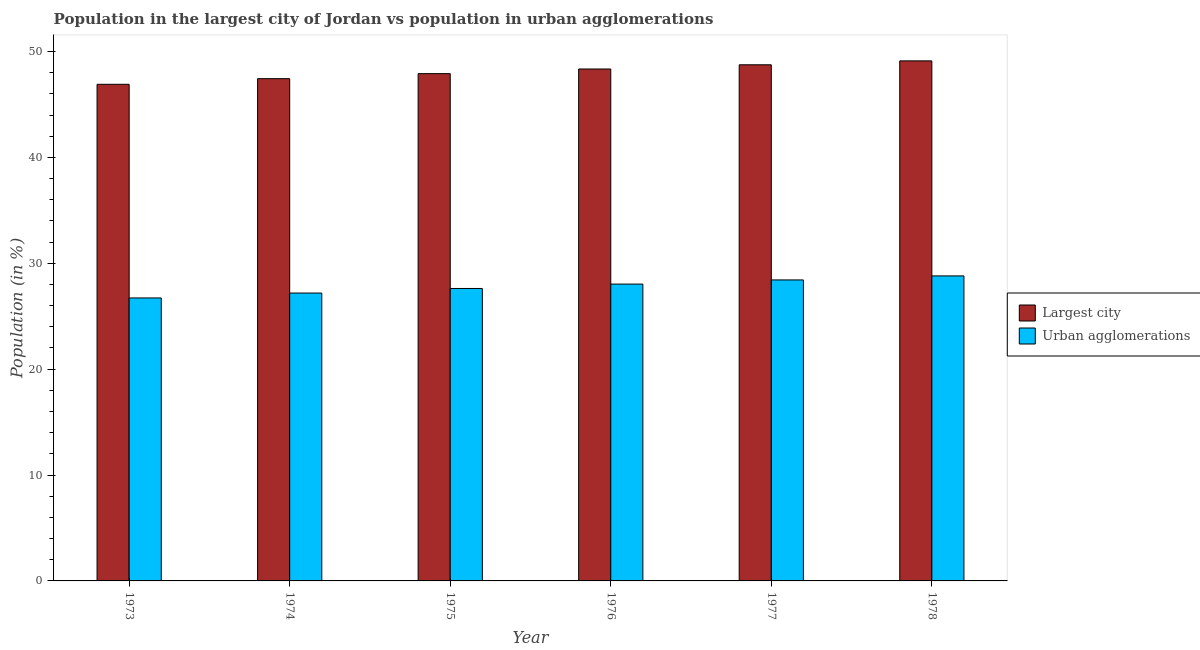How many different coloured bars are there?
Provide a short and direct response. 2. How many groups of bars are there?
Your answer should be very brief. 6. Are the number of bars per tick equal to the number of legend labels?
Offer a terse response. Yes. What is the label of the 6th group of bars from the left?
Provide a succinct answer. 1978. In how many cases, is the number of bars for a given year not equal to the number of legend labels?
Offer a very short reply. 0. What is the population in urban agglomerations in 1973?
Provide a succinct answer. 26.73. Across all years, what is the maximum population in urban agglomerations?
Your answer should be very brief. 28.81. Across all years, what is the minimum population in urban agglomerations?
Your response must be concise. 26.73. In which year was the population in the largest city maximum?
Offer a terse response. 1978. What is the total population in urban agglomerations in the graph?
Ensure brevity in your answer.  166.81. What is the difference between the population in urban agglomerations in 1973 and that in 1978?
Provide a short and direct response. -2.08. What is the difference between the population in the largest city in 1977 and the population in urban agglomerations in 1978?
Your answer should be very brief. -0.37. What is the average population in the largest city per year?
Offer a very short reply. 48.08. What is the ratio of the population in urban agglomerations in 1975 to that in 1978?
Your answer should be very brief. 0.96. Is the population in the largest city in 1975 less than that in 1978?
Offer a terse response. Yes. What is the difference between the highest and the second highest population in urban agglomerations?
Keep it short and to the point. 0.38. What is the difference between the highest and the lowest population in the largest city?
Make the answer very short. 2.21. In how many years, is the population in the largest city greater than the average population in the largest city taken over all years?
Offer a terse response. 3. What does the 2nd bar from the left in 1977 represents?
Your answer should be compact. Urban agglomerations. What does the 1st bar from the right in 1976 represents?
Offer a terse response. Urban agglomerations. How many bars are there?
Give a very brief answer. 12. Are all the bars in the graph horizontal?
Ensure brevity in your answer.  No. Does the graph contain grids?
Your answer should be compact. No. Where does the legend appear in the graph?
Make the answer very short. Center right. How are the legend labels stacked?
Your response must be concise. Vertical. What is the title of the graph?
Your answer should be compact. Population in the largest city of Jordan vs population in urban agglomerations. What is the label or title of the X-axis?
Give a very brief answer. Year. What is the label or title of the Y-axis?
Provide a short and direct response. Population (in %). What is the Population (in %) in Largest city in 1973?
Ensure brevity in your answer.  46.91. What is the Population (in %) of Urban agglomerations in 1973?
Make the answer very short. 26.73. What is the Population (in %) in Largest city in 1974?
Ensure brevity in your answer.  47.44. What is the Population (in %) of Urban agglomerations in 1974?
Keep it short and to the point. 27.19. What is the Population (in %) of Largest city in 1975?
Make the answer very short. 47.91. What is the Population (in %) in Urban agglomerations in 1975?
Ensure brevity in your answer.  27.62. What is the Population (in %) of Largest city in 1976?
Offer a terse response. 48.35. What is the Population (in %) in Urban agglomerations in 1976?
Make the answer very short. 28.04. What is the Population (in %) of Largest city in 1977?
Provide a succinct answer. 48.75. What is the Population (in %) of Urban agglomerations in 1977?
Your answer should be very brief. 28.43. What is the Population (in %) of Largest city in 1978?
Keep it short and to the point. 49.12. What is the Population (in %) of Urban agglomerations in 1978?
Give a very brief answer. 28.81. Across all years, what is the maximum Population (in %) of Largest city?
Offer a very short reply. 49.12. Across all years, what is the maximum Population (in %) in Urban agglomerations?
Offer a terse response. 28.81. Across all years, what is the minimum Population (in %) of Largest city?
Your answer should be very brief. 46.91. Across all years, what is the minimum Population (in %) in Urban agglomerations?
Offer a very short reply. 26.73. What is the total Population (in %) in Largest city in the graph?
Your answer should be very brief. 288.48. What is the total Population (in %) of Urban agglomerations in the graph?
Ensure brevity in your answer.  166.81. What is the difference between the Population (in %) of Largest city in 1973 and that in 1974?
Your answer should be compact. -0.53. What is the difference between the Population (in %) in Urban agglomerations in 1973 and that in 1974?
Keep it short and to the point. -0.46. What is the difference between the Population (in %) of Largest city in 1973 and that in 1975?
Give a very brief answer. -1.01. What is the difference between the Population (in %) in Urban agglomerations in 1973 and that in 1975?
Your response must be concise. -0.89. What is the difference between the Population (in %) in Largest city in 1973 and that in 1976?
Give a very brief answer. -1.45. What is the difference between the Population (in %) in Urban agglomerations in 1973 and that in 1976?
Make the answer very short. -1.31. What is the difference between the Population (in %) in Largest city in 1973 and that in 1977?
Your answer should be very brief. -1.84. What is the difference between the Population (in %) in Urban agglomerations in 1973 and that in 1977?
Ensure brevity in your answer.  -1.7. What is the difference between the Population (in %) of Largest city in 1973 and that in 1978?
Your answer should be compact. -2.21. What is the difference between the Population (in %) in Urban agglomerations in 1973 and that in 1978?
Provide a short and direct response. -2.08. What is the difference between the Population (in %) of Largest city in 1974 and that in 1975?
Ensure brevity in your answer.  -0.47. What is the difference between the Population (in %) in Urban agglomerations in 1974 and that in 1975?
Keep it short and to the point. -0.43. What is the difference between the Population (in %) of Largest city in 1974 and that in 1976?
Your answer should be compact. -0.91. What is the difference between the Population (in %) in Urban agglomerations in 1974 and that in 1976?
Your response must be concise. -0.85. What is the difference between the Population (in %) in Largest city in 1974 and that in 1977?
Ensure brevity in your answer.  -1.31. What is the difference between the Population (in %) of Urban agglomerations in 1974 and that in 1977?
Your answer should be compact. -1.24. What is the difference between the Population (in %) of Largest city in 1974 and that in 1978?
Provide a short and direct response. -1.68. What is the difference between the Population (in %) in Urban agglomerations in 1974 and that in 1978?
Provide a succinct answer. -1.62. What is the difference between the Population (in %) in Largest city in 1975 and that in 1976?
Your answer should be very brief. -0.44. What is the difference between the Population (in %) in Urban agglomerations in 1975 and that in 1976?
Your answer should be very brief. -0.41. What is the difference between the Population (in %) in Largest city in 1975 and that in 1977?
Give a very brief answer. -0.84. What is the difference between the Population (in %) of Urban agglomerations in 1975 and that in 1977?
Provide a short and direct response. -0.81. What is the difference between the Population (in %) in Largest city in 1975 and that in 1978?
Your answer should be compact. -1.21. What is the difference between the Population (in %) in Urban agglomerations in 1975 and that in 1978?
Ensure brevity in your answer.  -1.19. What is the difference between the Population (in %) of Largest city in 1976 and that in 1977?
Provide a succinct answer. -0.4. What is the difference between the Population (in %) of Urban agglomerations in 1976 and that in 1977?
Offer a terse response. -0.39. What is the difference between the Population (in %) of Largest city in 1976 and that in 1978?
Provide a short and direct response. -0.77. What is the difference between the Population (in %) in Urban agglomerations in 1976 and that in 1978?
Your answer should be very brief. -0.77. What is the difference between the Population (in %) of Largest city in 1977 and that in 1978?
Your answer should be very brief. -0.37. What is the difference between the Population (in %) of Urban agglomerations in 1977 and that in 1978?
Offer a terse response. -0.38. What is the difference between the Population (in %) in Largest city in 1973 and the Population (in %) in Urban agglomerations in 1974?
Keep it short and to the point. 19.72. What is the difference between the Population (in %) in Largest city in 1973 and the Population (in %) in Urban agglomerations in 1975?
Provide a short and direct response. 19.28. What is the difference between the Population (in %) in Largest city in 1973 and the Population (in %) in Urban agglomerations in 1976?
Give a very brief answer. 18.87. What is the difference between the Population (in %) of Largest city in 1973 and the Population (in %) of Urban agglomerations in 1977?
Provide a succinct answer. 18.48. What is the difference between the Population (in %) in Largest city in 1973 and the Population (in %) in Urban agglomerations in 1978?
Your response must be concise. 18.1. What is the difference between the Population (in %) in Largest city in 1974 and the Population (in %) in Urban agglomerations in 1975?
Your answer should be compact. 19.82. What is the difference between the Population (in %) in Largest city in 1974 and the Population (in %) in Urban agglomerations in 1976?
Offer a very short reply. 19.4. What is the difference between the Population (in %) of Largest city in 1974 and the Population (in %) of Urban agglomerations in 1977?
Your response must be concise. 19.01. What is the difference between the Population (in %) in Largest city in 1974 and the Population (in %) in Urban agglomerations in 1978?
Keep it short and to the point. 18.63. What is the difference between the Population (in %) of Largest city in 1975 and the Population (in %) of Urban agglomerations in 1976?
Keep it short and to the point. 19.88. What is the difference between the Population (in %) in Largest city in 1975 and the Population (in %) in Urban agglomerations in 1977?
Provide a short and direct response. 19.48. What is the difference between the Population (in %) in Largest city in 1975 and the Population (in %) in Urban agglomerations in 1978?
Make the answer very short. 19.11. What is the difference between the Population (in %) in Largest city in 1976 and the Population (in %) in Urban agglomerations in 1977?
Your answer should be compact. 19.92. What is the difference between the Population (in %) of Largest city in 1976 and the Population (in %) of Urban agglomerations in 1978?
Offer a very short reply. 19.54. What is the difference between the Population (in %) of Largest city in 1977 and the Population (in %) of Urban agglomerations in 1978?
Provide a succinct answer. 19.94. What is the average Population (in %) of Largest city per year?
Keep it short and to the point. 48.08. What is the average Population (in %) in Urban agglomerations per year?
Offer a very short reply. 27.8. In the year 1973, what is the difference between the Population (in %) in Largest city and Population (in %) in Urban agglomerations?
Offer a very short reply. 20.18. In the year 1974, what is the difference between the Population (in %) in Largest city and Population (in %) in Urban agglomerations?
Provide a short and direct response. 20.25. In the year 1975, what is the difference between the Population (in %) in Largest city and Population (in %) in Urban agglomerations?
Offer a terse response. 20.29. In the year 1976, what is the difference between the Population (in %) in Largest city and Population (in %) in Urban agglomerations?
Ensure brevity in your answer.  20.32. In the year 1977, what is the difference between the Population (in %) of Largest city and Population (in %) of Urban agglomerations?
Your response must be concise. 20.32. In the year 1978, what is the difference between the Population (in %) of Largest city and Population (in %) of Urban agglomerations?
Offer a terse response. 20.31. What is the ratio of the Population (in %) in Largest city in 1973 to that in 1975?
Your answer should be very brief. 0.98. What is the ratio of the Population (in %) in Urban agglomerations in 1973 to that in 1975?
Give a very brief answer. 0.97. What is the ratio of the Population (in %) in Largest city in 1973 to that in 1976?
Your answer should be very brief. 0.97. What is the ratio of the Population (in %) of Urban agglomerations in 1973 to that in 1976?
Make the answer very short. 0.95. What is the ratio of the Population (in %) in Largest city in 1973 to that in 1977?
Give a very brief answer. 0.96. What is the ratio of the Population (in %) of Urban agglomerations in 1973 to that in 1977?
Ensure brevity in your answer.  0.94. What is the ratio of the Population (in %) in Largest city in 1973 to that in 1978?
Your answer should be very brief. 0.95. What is the ratio of the Population (in %) of Urban agglomerations in 1973 to that in 1978?
Offer a very short reply. 0.93. What is the ratio of the Population (in %) of Largest city in 1974 to that in 1975?
Offer a very short reply. 0.99. What is the ratio of the Population (in %) in Urban agglomerations in 1974 to that in 1975?
Offer a terse response. 0.98. What is the ratio of the Population (in %) in Largest city in 1974 to that in 1976?
Your response must be concise. 0.98. What is the ratio of the Population (in %) of Urban agglomerations in 1974 to that in 1976?
Offer a terse response. 0.97. What is the ratio of the Population (in %) in Largest city in 1974 to that in 1977?
Offer a terse response. 0.97. What is the ratio of the Population (in %) of Urban agglomerations in 1974 to that in 1977?
Make the answer very short. 0.96. What is the ratio of the Population (in %) in Largest city in 1974 to that in 1978?
Your answer should be very brief. 0.97. What is the ratio of the Population (in %) in Urban agglomerations in 1974 to that in 1978?
Your answer should be very brief. 0.94. What is the ratio of the Population (in %) in Largest city in 1975 to that in 1976?
Your answer should be very brief. 0.99. What is the ratio of the Population (in %) of Urban agglomerations in 1975 to that in 1976?
Provide a succinct answer. 0.99. What is the ratio of the Population (in %) in Largest city in 1975 to that in 1977?
Ensure brevity in your answer.  0.98. What is the ratio of the Population (in %) of Urban agglomerations in 1975 to that in 1977?
Offer a terse response. 0.97. What is the ratio of the Population (in %) of Largest city in 1975 to that in 1978?
Keep it short and to the point. 0.98. What is the ratio of the Population (in %) in Urban agglomerations in 1975 to that in 1978?
Keep it short and to the point. 0.96. What is the ratio of the Population (in %) in Urban agglomerations in 1976 to that in 1977?
Your response must be concise. 0.99. What is the ratio of the Population (in %) in Largest city in 1976 to that in 1978?
Give a very brief answer. 0.98. What is the ratio of the Population (in %) of Urban agglomerations in 1976 to that in 1978?
Provide a succinct answer. 0.97. What is the ratio of the Population (in %) of Largest city in 1977 to that in 1978?
Ensure brevity in your answer.  0.99. What is the ratio of the Population (in %) in Urban agglomerations in 1977 to that in 1978?
Offer a terse response. 0.99. What is the difference between the highest and the second highest Population (in %) of Largest city?
Make the answer very short. 0.37. What is the difference between the highest and the second highest Population (in %) in Urban agglomerations?
Offer a terse response. 0.38. What is the difference between the highest and the lowest Population (in %) in Largest city?
Offer a terse response. 2.21. What is the difference between the highest and the lowest Population (in %) of Urban agglomerations?
Offer a terse response. 2.08. 